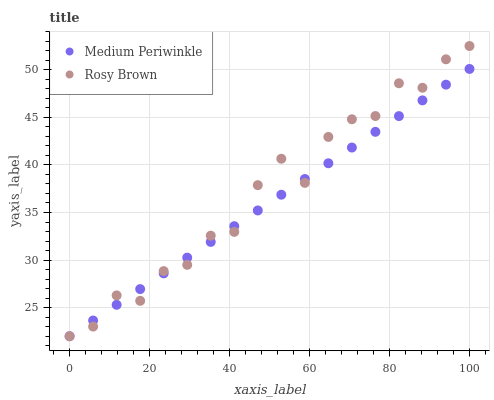Does Medium Periwinkle have the minimum area under the curve?
Answer yes or no. Yes. Does Rosy Brown have the maximum area under the curve?
Answer yes or no. Yes. Does Medium Periwinkle have the maximum area under the curve?
Answer yes or no. No. Is Medium Periwinkle the smoothest?
Answer yes or no. Yes. Is Rosy Brown the roughest?
Answer yes or no. Yes. Is Medium Periwinkle the roughest?
Answer yes or no. No. Does Rosy Brown have the lowest value?
Answer yes or no. Yes. Does Rosy Brown have the highest value?
Answer yes or no. Yes. Does Medium Periwinkle have the highest value?
Answer yes or no. No. Does Medium Periwinkle intersect Rosy Brown?
Answer yes or no. Yes. Is Medium Periwinkle less than Rosy Brown?
Answer yes or no. No. Is Medium Periwinkle greater than Rosy Brown?
Answer yes or no. No. 